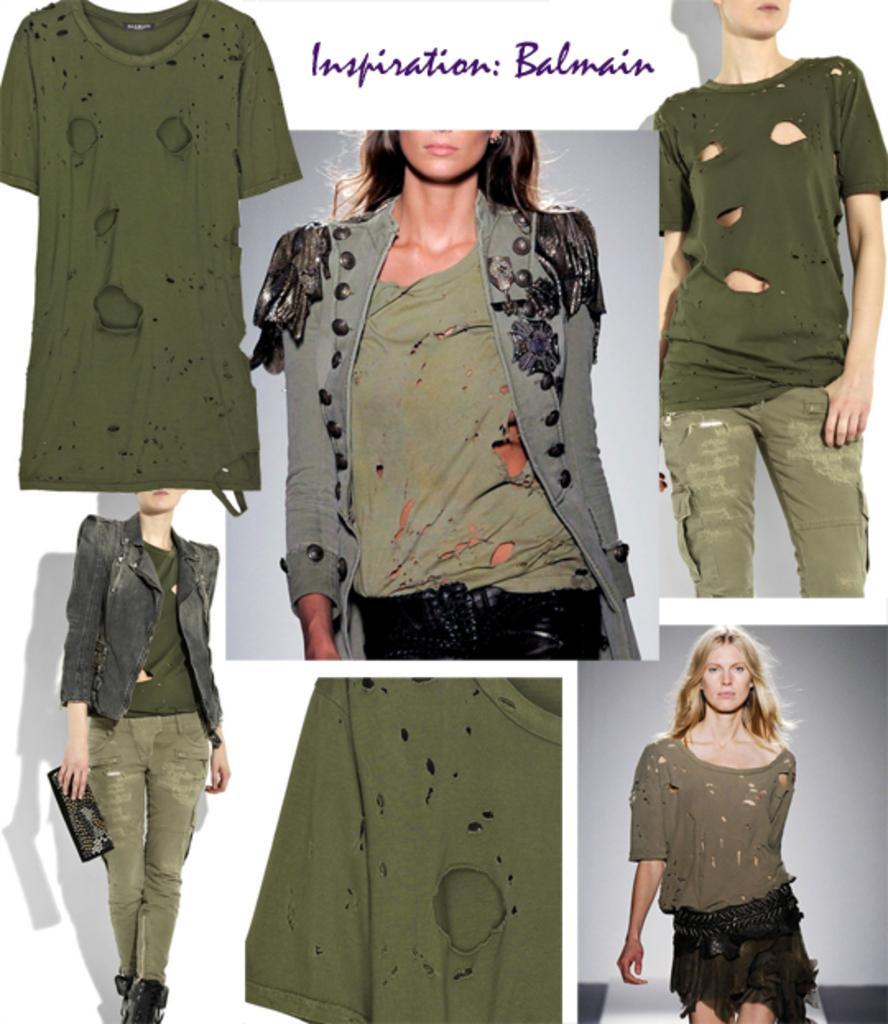Describe this image in one or two sentences. In this picture there are six collage photograph of the girl wearing a green color tones t-shirt and walking on the ramp. 